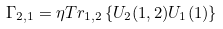Convert formula to latex. <formula><loc_0><loc_0><loc_500><loc_500>\Gamma _ { 2 , 1 } = \eta T r _ { 1 , 2 } \left \{ U _ { 2 } ( 1 , 2 ) U _ { 1 } ( 1 ) \right \}</formula> 